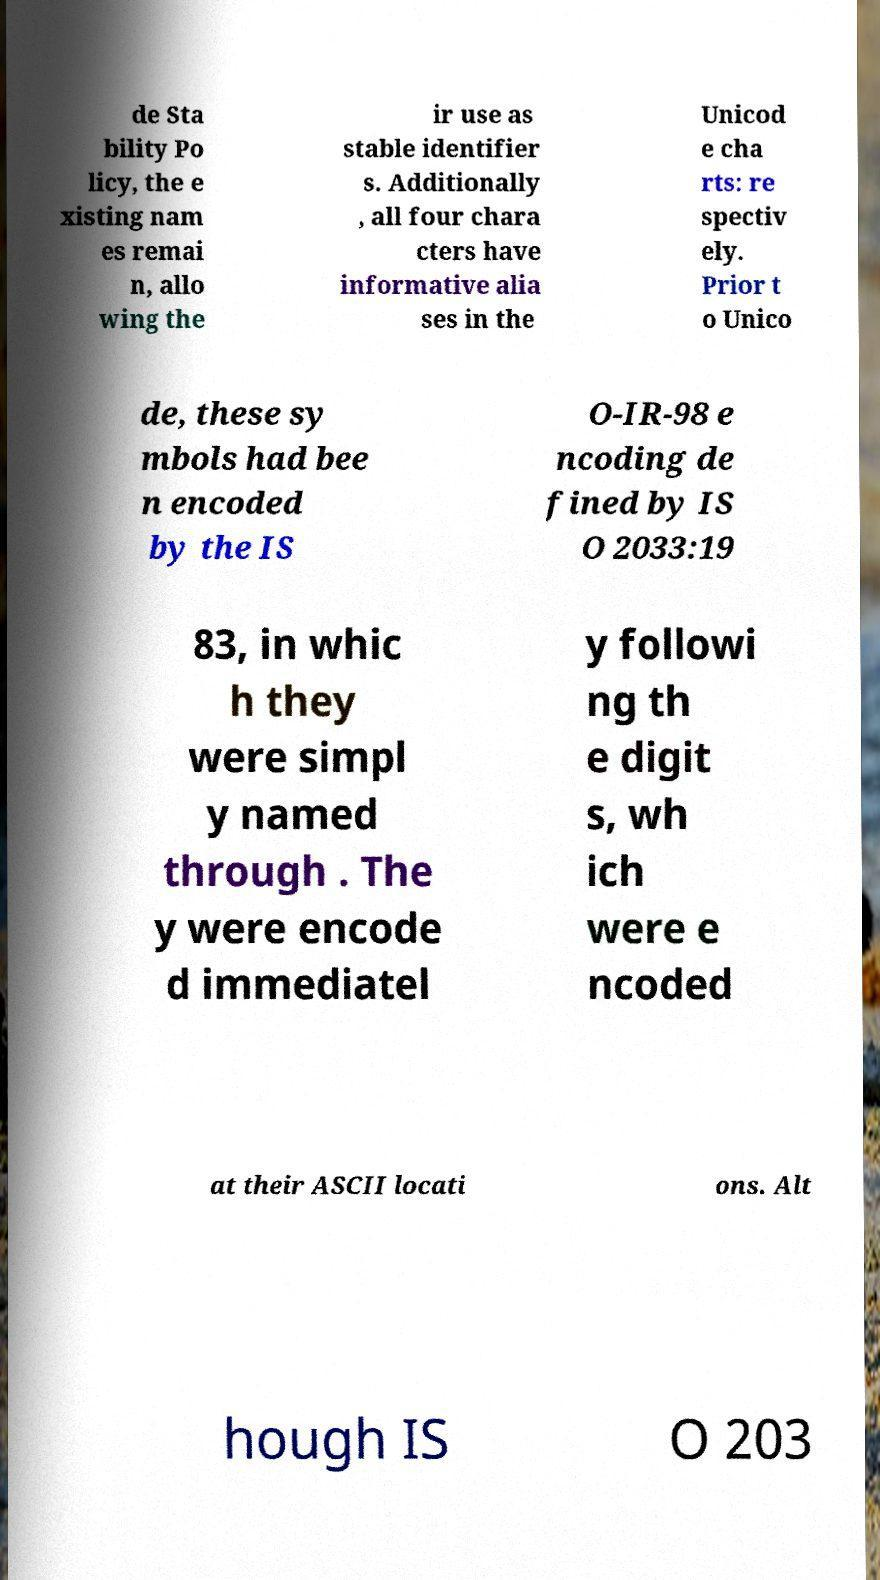Could you extract and type out the text from this image? de Sta bility Po licy, the e xisting nam es remai n, allo wing the ir use as stable identifier s. Additionally , all four chara cters have informative alia ses in the Unicod e cha rts: re spectiv ely. Prior t o Unico de, these sy mbols had bee n encoded by the IS O-IR-98 e ncoding de fined by IS O 2033:19 83, in whic h they were simpl y named through . The y were encode d immediatel y followi ng th e digit s, wh ich were e ncoded at their ASCII locati ons. Alt hough IS O 203 